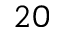<formula> <loc_0><loc_0><loc_500><loc_500>2 0</formula> 